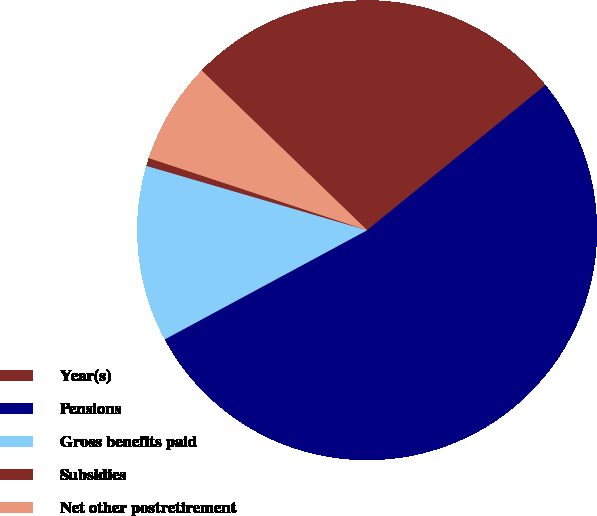Convert chart. <chart><loc_0><loc_0><loc_500><loc_500><pie_chart><fcel>Year(s)<fcel>Pensions<fcel>Gross benefits paid<fcel>Subsidies<fcel>Net other postretirement<nl><fcel>26.91%<fcel>53.0%<fcel>12.39%<fcel>0.56%<fcel>7.14%<nl></chart> 